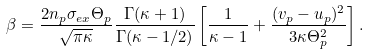Convert formula to latex. <formula><loc_0><loc_0><loc_500><loc_500>\beta = \frac { 2 n _ { p } \sigma _ { e x } \Theta _ { p } } { \sqrt { \pi \kappa } } \frac { \Gamma ( \kappa + 1 ) } { \Gamma ( \kappa - 1 / 2 ) } \left [ \frac { 1 } { \kappa - 1 } + \frac { ( { v } _ { p } - { u } _ { p } ) ^ { 2 } } { 3 \kappa \Theta _ { p } ^ { 2 } } \right ] .</formula> 